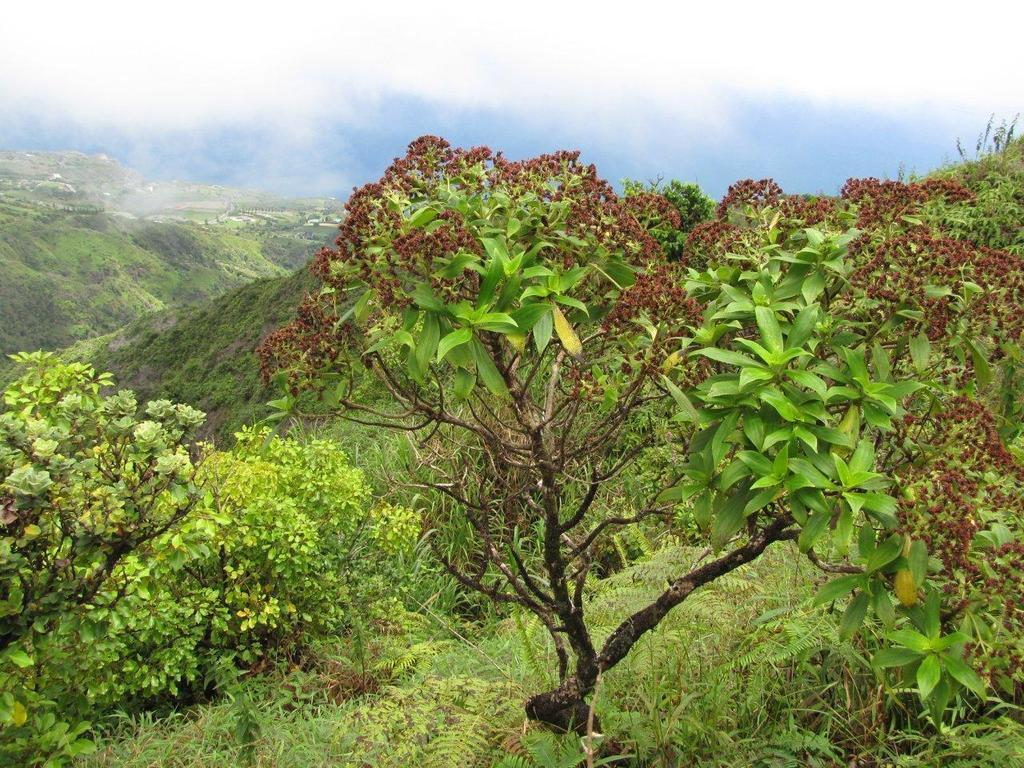What type of vegetation can be seen in the image? There are trees, plants, and grass in the image. Can you describe the sky in the image? The sky is cloudy in the image. What type of soup is being served in the image? There is no soup present in the image; it features trees, plants, grass, and a cloudy sky. Can you tell me what print is on the ball in the image? There is no ball present in the image. 